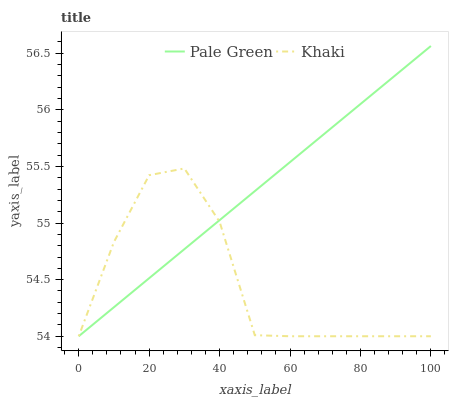Does Khaki have the maximum area under the curve?
Answer yes or no. No. Is Khaki the smoothest?
Answer yes or no. No. Does Khaki have the highest value?
Answer yes or no. No. 